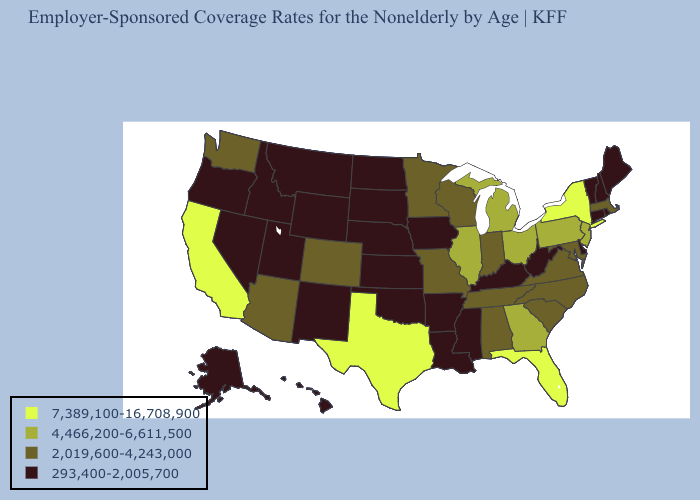Name the states that have a value in the range 4,466,200-6,611,500?
Write a very short answer. Georgia, Illinois, Michigan, New Jersey, Ohio, Pennsylvania. Among the states that border Oklahoma , does Colorado have the highest value?
Answer briefly. No. Name the states that have a value in the range 293,400-2,005,700?
Concise answer only. Alaska, Arkansas, Connecticut, Delaware, Hawaii, Idaho, Iowa, Kansas, Kentucky, Louisiana, Maine, Mississippi, Montana, Nebraska, Nevada, New Hampshire, New Mexico, North Dakota, Oklahoma, Oregon, Rhode Island, South Dakota, Utah, Vermont, West Virginia, Wyoming. What is the value of Indiana?
Concise answer only. 2,019,600-4,243,000. Name the states that have a value in the range 2,019,600-4,243,000?
Keep it brief. Alabama, Arizona, Colorado, Indiana, Maryland, Massachusetts, Minnesota, Missouri, North Carolina, South Carolina, Tennessee, Virginia, Washington, Wisconsin. Among the states that border Illinois , which have the lowest value?
Concise answer only. Iowa, Kentucky. Name the states that have a value in the range 2,019,600-4,243,000?
Answer briefly. Alabama, Arizona, Colorado, Indiana, Maryland, Massachusetts, Minnesota, Missouri, North Carolina, South Carolina, Tennessee, Virginia, Washington, Wisconsin. Among the states that border New Mexico , does Texas have the highest value?
Write a very short answer. Yes. Name the states that have a value in the range 293,400-2,005,700?
Short answer required. Alaska, Arkansas, Connecticut, Delaware, Hawaii, Idaho, Iowa, Kansas, Kentucky, Louisiana, Maine, Mississippi, Montana, Nebraska, Nevada, New Hampshire, New Mexico, North Dakota, Oklahoma, Oregon, Rhode Island, South Dakota, Utah, Vermont, West Virginia, Wyoming. How many symbols are there in the legend?
Keep it brief. 4. Name the states that have a value in the range 293,400-2,005,700?
Quick response, please. Alaska, Arkansas, Connecticut, Delaware, Hawaii, Idaho, Iowa, Kansas, Kentucky, Louisiana, Maine, Mississippi, Montana, Nebraska, Nevada, New Hampshire, New Mexico, North Dakota, Oklahoma, Oregon, Rhode Island, South Dakota, Utah, Vermont, West Virginia, Wyoming. Does Vermont have the lowest value in the Northeast?
Give a very brief answer. Yes. What is the value of Oregon?
Answer briefly. 293,400-2,005,700. What is the lowest value in the MidWest?
Keep it brief. 293,400-2,005,700. Name the states that have a value in the range 7,389,100-16,708,900?
Concise answer only. California, Florida, New York, Texas. 